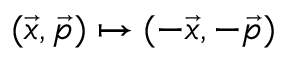<formula> <loc_0><loc_0><loc_500><loc_500>( \vec { x } , \vec { p } ) \mapsto ( - \vec { x } , - \vec { p } )</formula> 